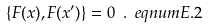Convert formula to latex. <formula><loc_0><loc_0><loc_500><loc_500>\{ F ( x ) , F ( x ^ { \prime } ) \} = 0 \ . \ e q n u m { E . 2 }</formula> 